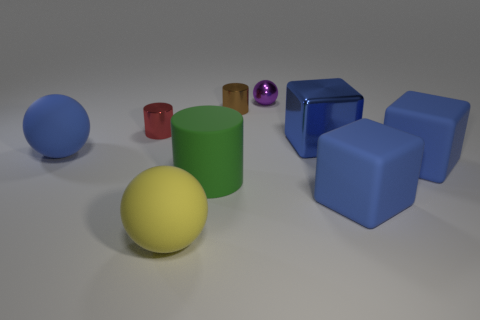Subtract all tiny purple shiny spheres. How many spheres are left? 2 Add 1 large green cylinders. How many objects exist? 10 Subtract all brown cylinders. How many cylinders are left? 2 Subtract all blue cylinders. Subtract all green spheres. How many cylinders are left? 3 Subtract all metal spheres. Subtract all large green rubber things. How many objects are left? 7 Add 9 brown cylinders. How many brown cylinders are left? 10 Add 8 big blue rubber balls. How many big blue rubber balls exist? 9 Subtract 0 brown cubes. How many objects are left? 9 Subtract all cubes. How many objects are left? 6 Subtract 1 cylinders. How many cylinders are left? 2 